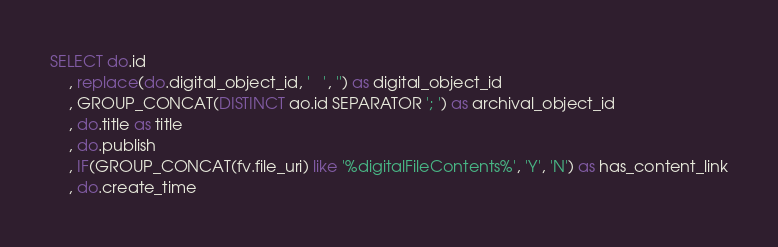Convert code to text. <code><loc_0><loc_0><loc_500><loc_500><_SQL_>SELECT do.id
	, replace(do.digital_object_id, '	', '') as digital_object_id
	, GROUP_CONCAT(DISTINCT ao.id SEPARATOR '; ') as archival_object_id
	, do.title as title
	, do.publish
	, IF(GROUP_CONCAT(fv.file_uri) like '%digitalFileContents%', 'Y', 'N') as has_content_link
	, do.create_time</code> 